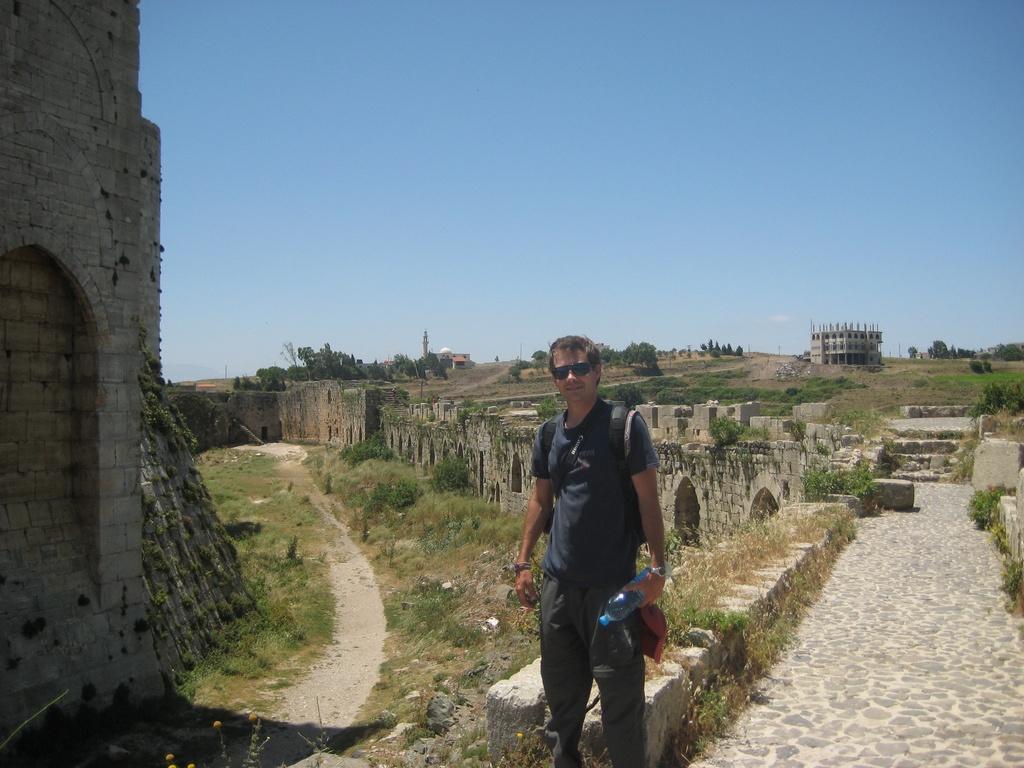How would you summarize this image in a sentence or two? In this image I can see the person wearing the dress and holding the bottle. I can see many forts and plants. In the background I can see the building, many trees and the sky. 